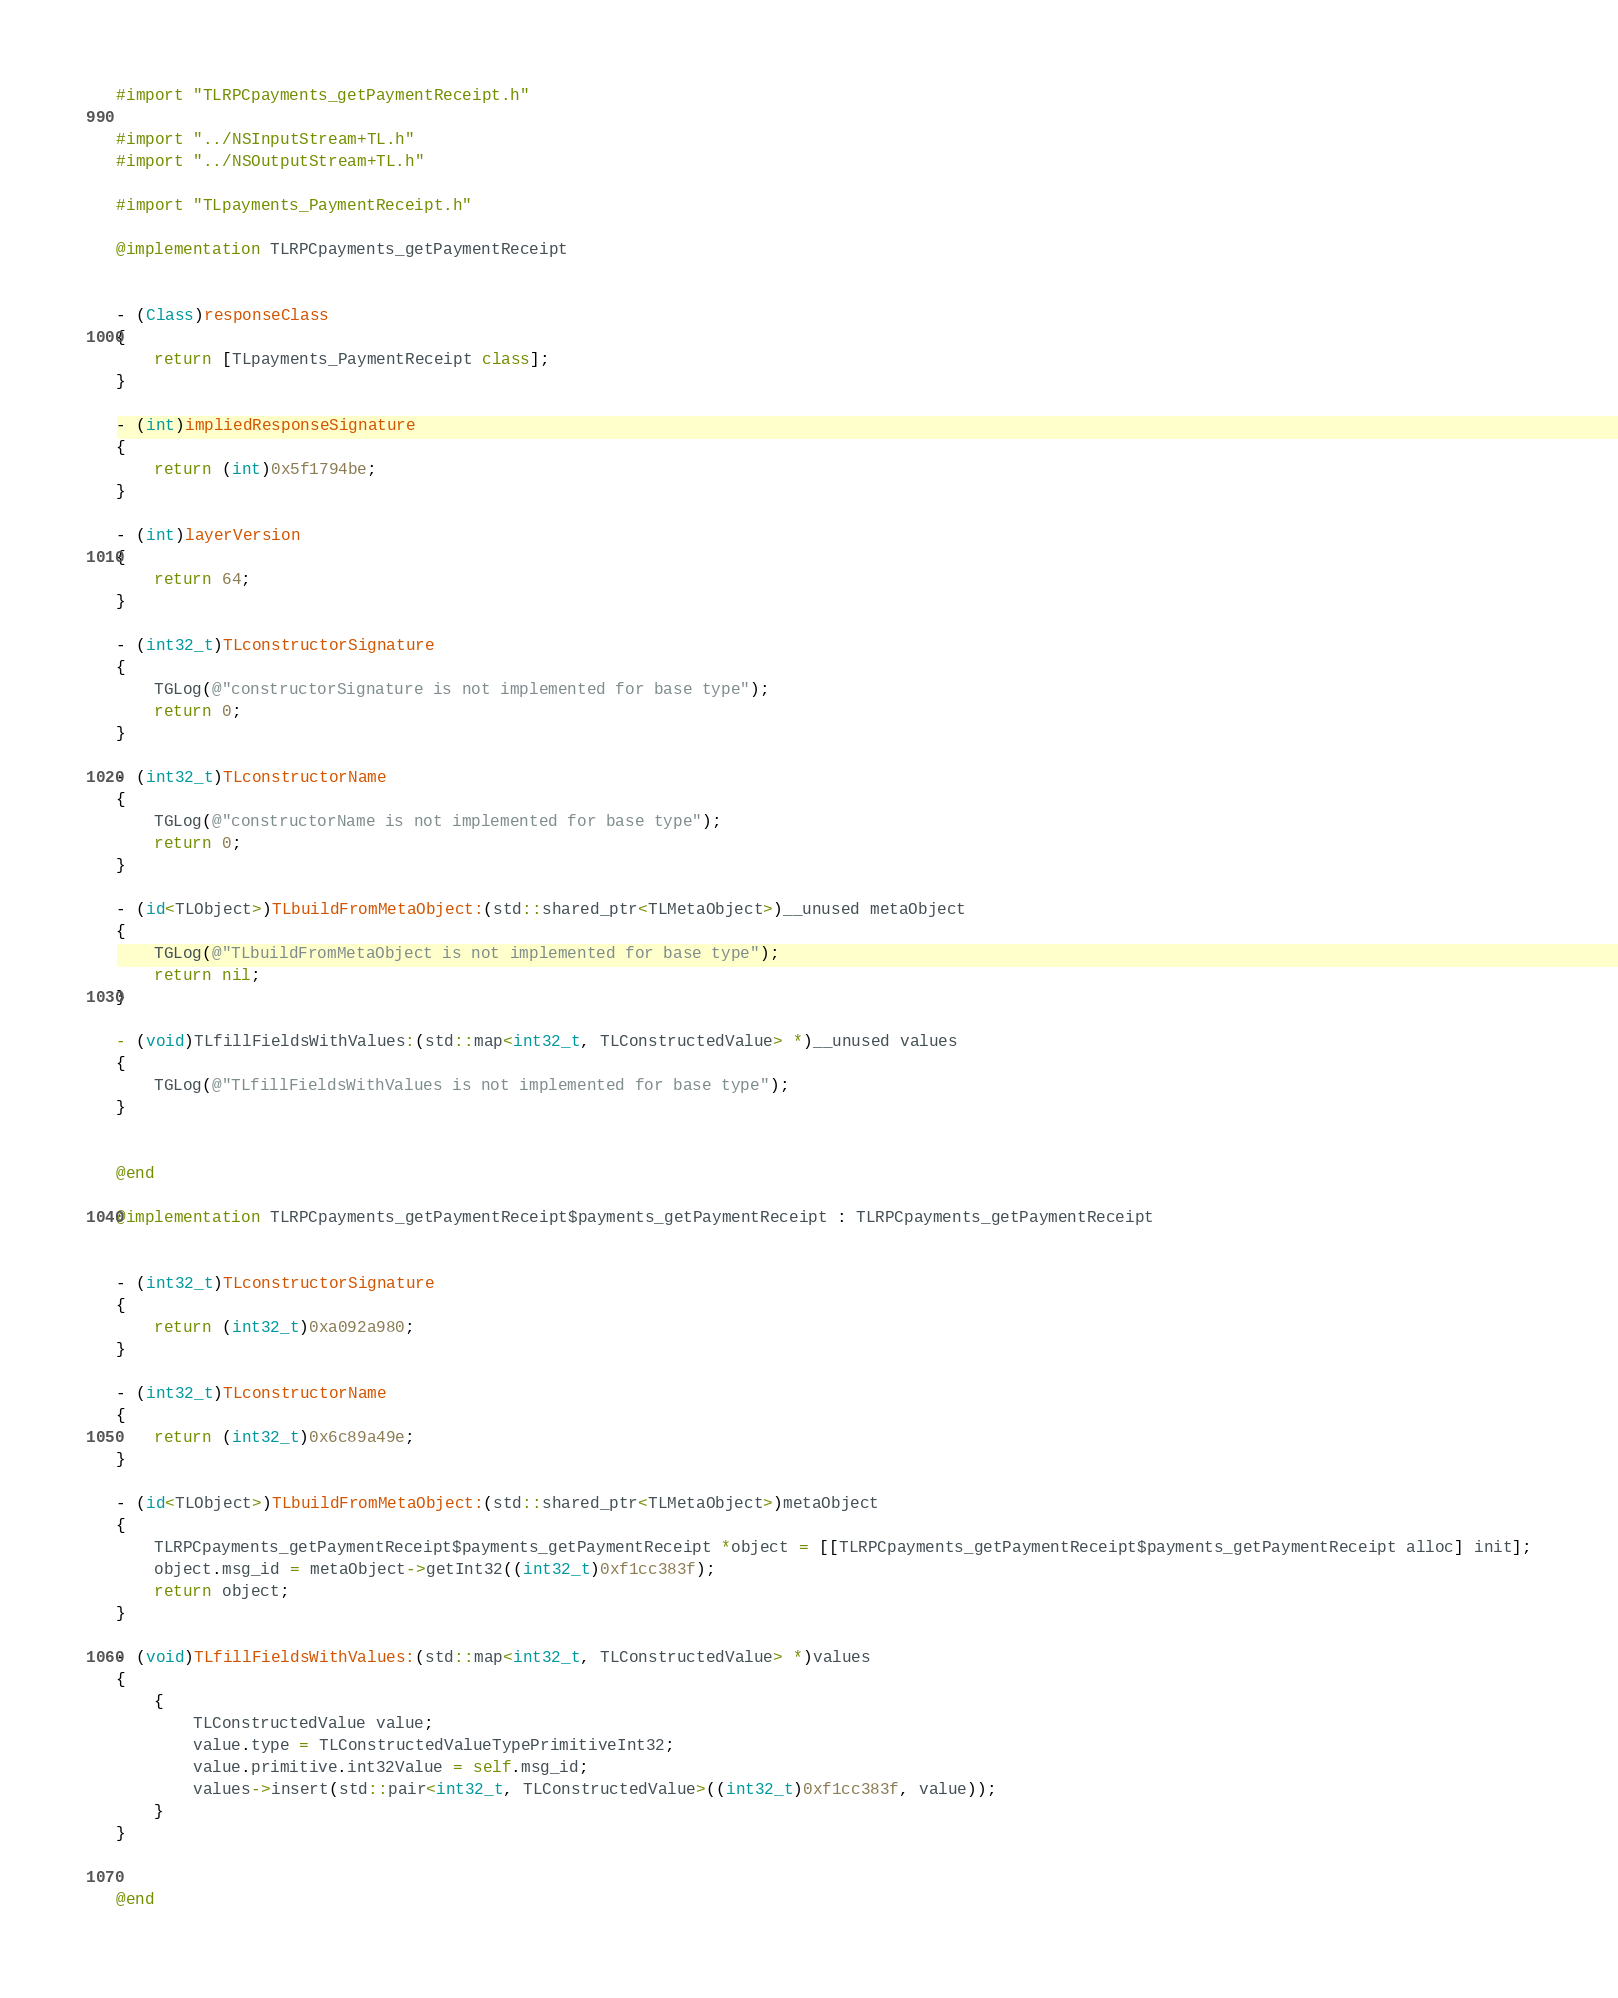<code> <loc_0><loc_0><loc_500><loc_500><_ObjectiveC_>#import "TLRPCpayments_getPaymentReceipt.h"

#import "../NSInputStream+TL.h"
#import "../NSOutputStream+TL.h"

#import "TLpayments_PaymentReceipt.h"

@implementation TLRPCpayments_getPaymentReceipt


- (Class)responseClass
{
    return [TLpayments_PaymentReceipt class];
}

- (int)impliedResponseSignature
{
    return (int)0x5f1794be;
}

- (int)layerVersion
{
    return 64;
}

- (int32_t)TLconstructorSignature
{
    TGLog(@"constructorSignature is not implemented for base type");
    return 0;
}

- (int32_t)TLconstructorName
{
    TGLog(@"constructorName is not implemented for base type");
    return 0;
}

- (id<TLObject>)TLbuildFromMetaObject:(std::shared_ptr<TLMetaObject>)__unused metaObject
{
    TGLog(@"TLbuildFromMetaObject is not implemented for base type");
    return nil;
}

- (void)TLfillFieldsWithValues:(std::map<int32_t, TLConstructedValue> *)__unused values
{
    TGLog(@"TLfillFieldsWithValues is not implemented for base type");
}


@end

@implementation TLRPCpayments_getPaymentReceipt$payments_getPaymentReceipt : TLRPCpayments_getPaymentReceipt


- (int32_t)TLconstructorSignature
{
    return (int32_t)0xa092a980;
}

- (int32_t)TLconstructorName
{
    return (int32_t)0x6c89a49e;
}

- (id<TLObject>)TLbuildFromMetaObject:(std::shared_ptr<TLMetaObject>)metaObject
{
    TLRPCpayments_getPaymentReceipt$payments_getPaymentReceipt *object = [[TLRPCpayments_getPaymentReceipt$payments_getPaymentReceipt alloc] init];
    object.msg_id = metaObject->getInt32((int32_t)0xf1cc383f);
    return object;
}

- (void)TLfillFieldsWithValues:(std::map<int32_t, TLConstructedValue> *)values
{
    {
        TLConstructedValue value;
        value.type = TLConstructedValueTypePrimitiveInt32;
        value.primitive.int32Value = self.msg_id;
        values->insert(std::pair<int32_t, TLConstructedValue>((int32_t)0xf1cc383f, value));
    }
}


@end

</code> 